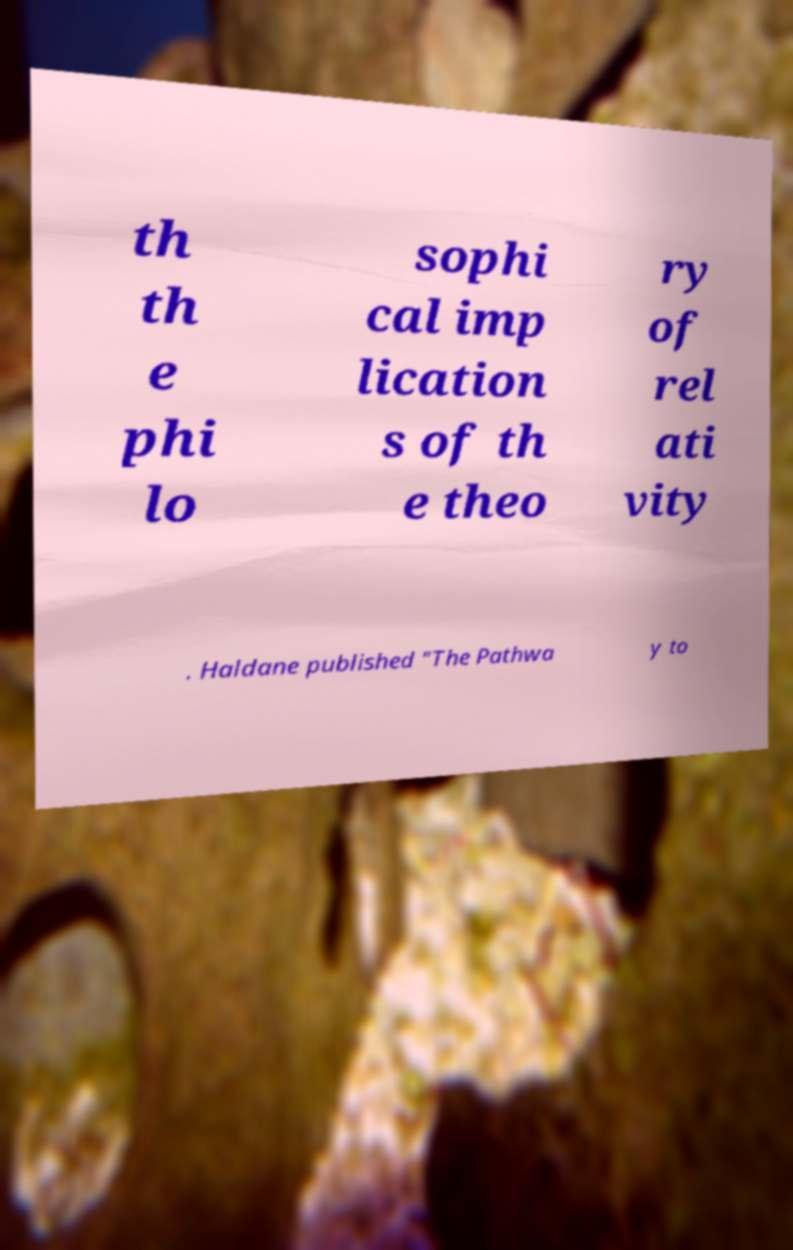There's text embedded in this image that I need extracted. Can you transcribe it verbatim? th th e phi lo sophi cal imp lication s of th e theo ry of rel ati vity . Haldane published "The Pathwa y to 